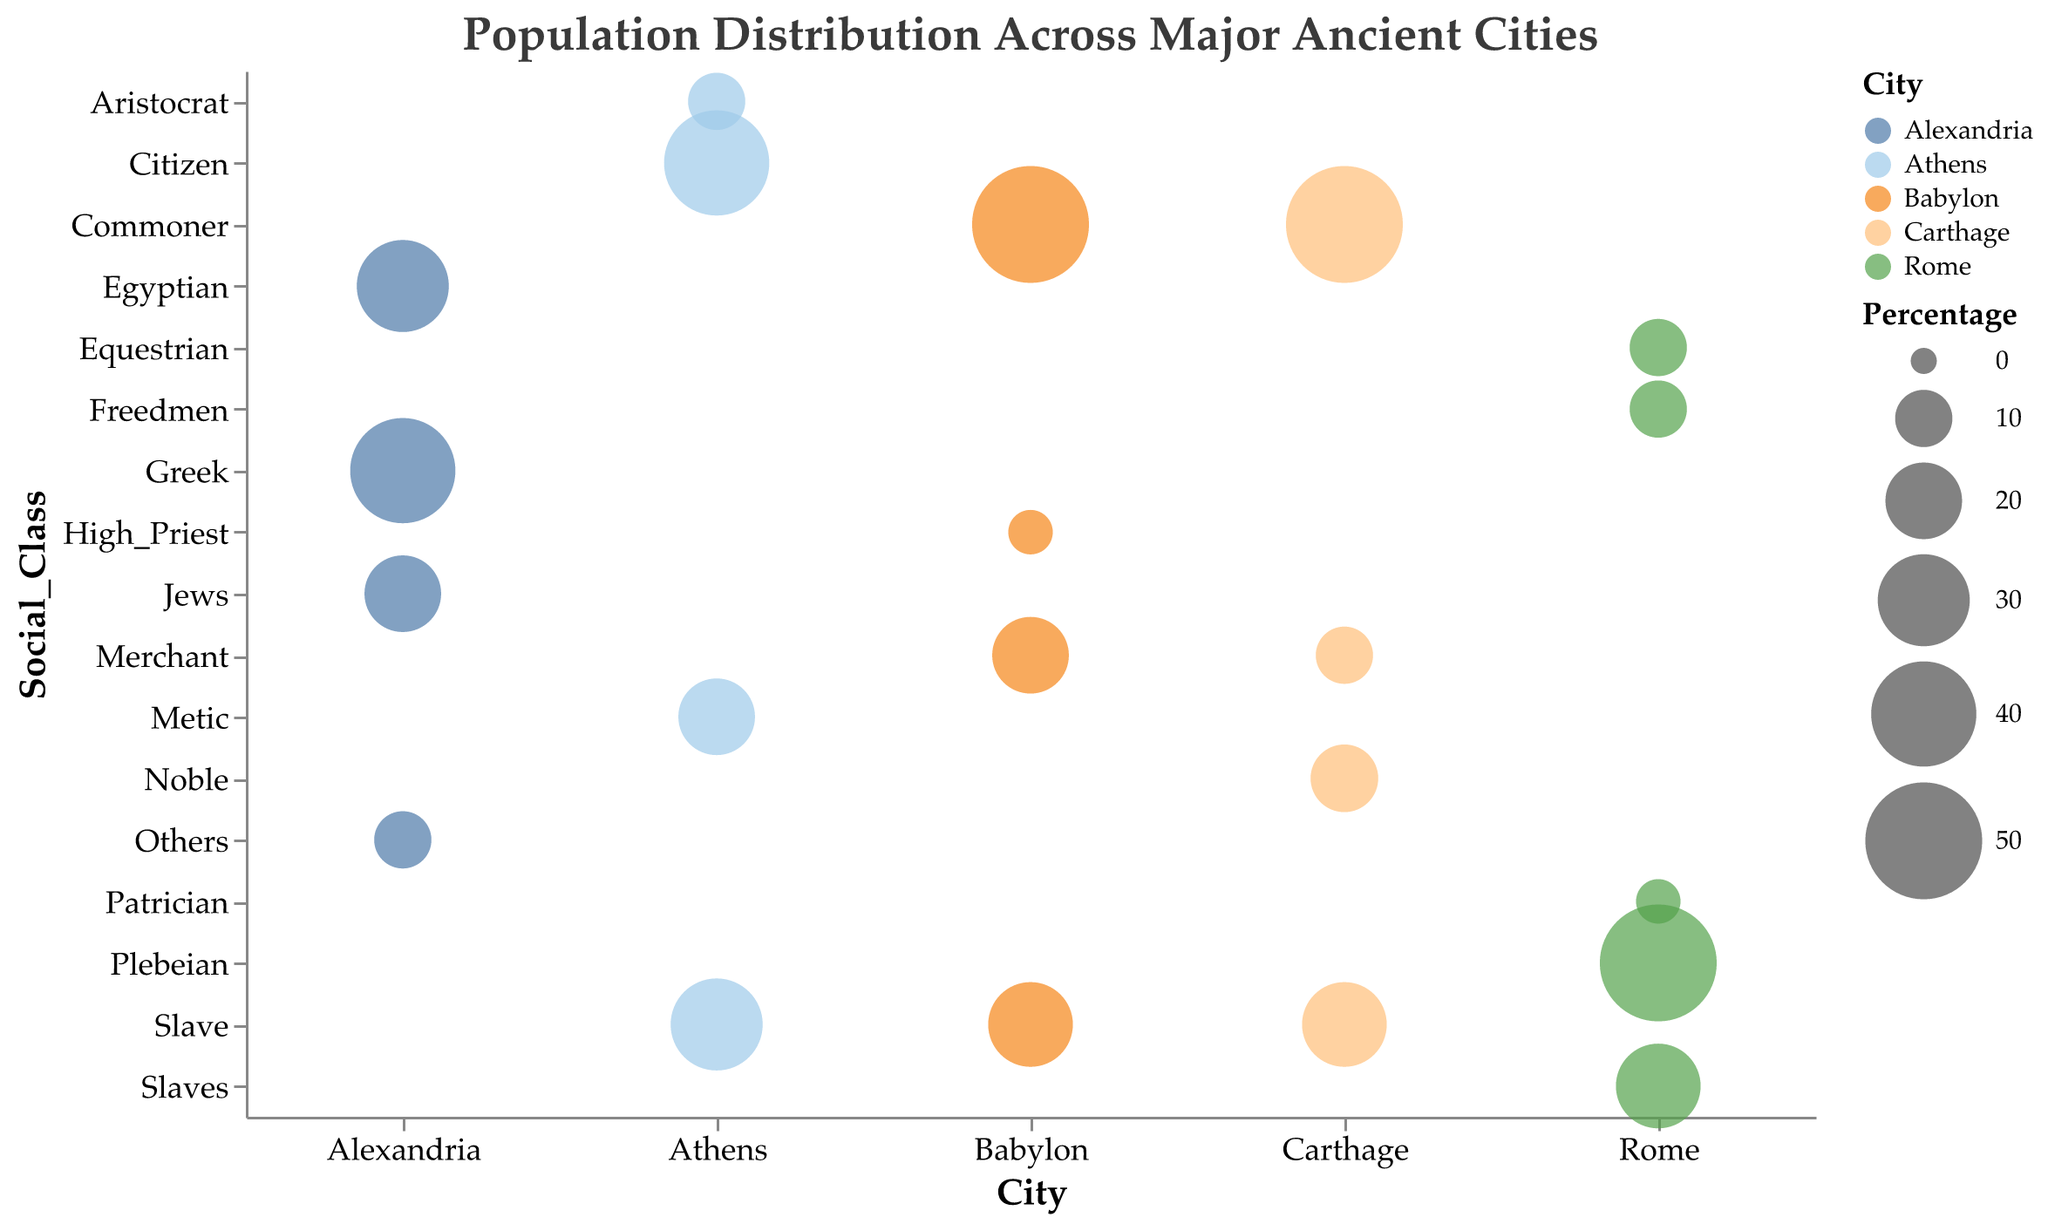What city has the highest overall population in the chart? The city with the highest population bubble size (and tooltip value) is Rome, with a population of 1,000,000.
Answer: Rome Which city has the largest proportion of the "Commoner" social class? By inspecting the size of bubbles and the tooltip percentage for the "Commoner" social class across all cities, Carthage is the one with 50%.
Answer: Carthage What is the smallest social class percentage depicted on the chart? The smallest bubble sizes represent social class percentages of 5%, which is shown for Patricians in Rome and High Priests in Babylon.
Answer: 5% Compare the percentage of slaves in Carthage and Babylon. Which city has more? By comparing the bubble sizes and tooltip percentages in both cities for the "Slave" category, Carthage shows 25% and Babylon also shows 25%.
Answer: Equal How many social classes are represented in Alexandria? Count the number of bubbles above the city name Alexandria: Greek, Egyptian, Jews, and Others.
Answer: 4 What is the total population of Athens if each class is represented by different people? In Athens, there are 4 social classes with percentages shown. Since percentages add to 100%, the total population is 150,000 people.
Answer: 150,000 In which city is the "Merchant" class most prominent by percentage? Comparing the bubble sizes and tooltip percentages for the "Merchant" social class in both Carthage and Babylon, Carthage has 10% while Babylon has 20%.
Answer: Babylon Find the sum of the population percentages for non-slave classes in Carthage. In Carthage, the non-slave classes (Noble, Commoner, Merchant) have percentages 15% + 50% + 10%. Summing these gives 75%.
Answer: 75% Which city has the most evenly distributed social classes in terms of percentage? Rome and Babylon both have social classes with significant representation, but Rome stands out with more evenly hit percentages among Plebeian, Slaves, Freedmen, Equestrian.
Answer: Rome How does the distribution of social classes in Athens compare to Alexandria in terms of diversity? Athens shows 10% Aristocrat, 20% Metic, 30% Slave, 40% Citizen. Alexandria shows 40% Greek, 30% Egyptian, 20% Jews, 10% Others. Both cities have diverse distributions, but Alexandria's percentages have a descending order and seem less stratified.
Answer: Alexandria is less stratified 